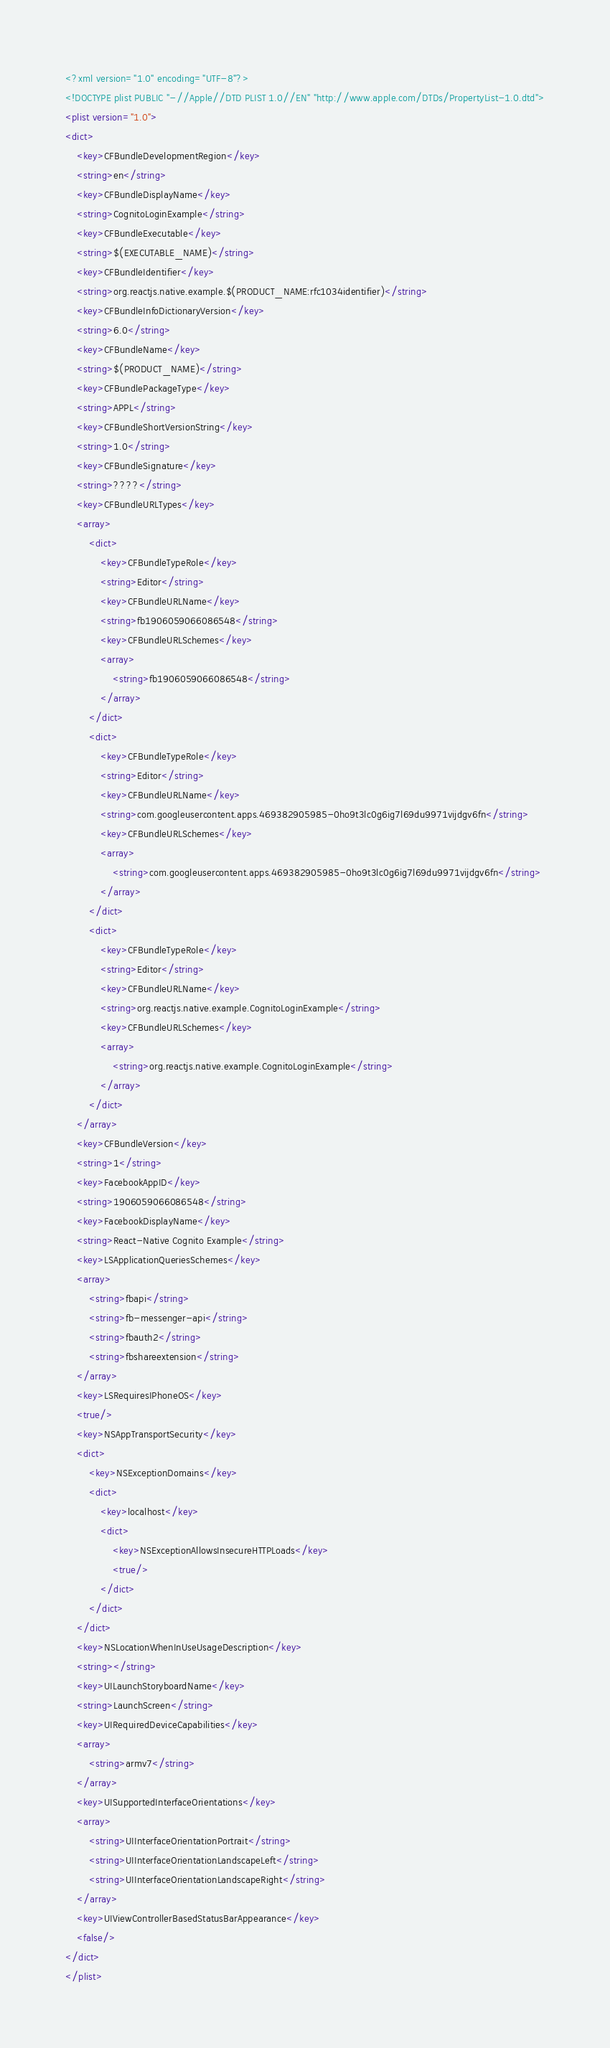<code> <loc_0><loc_0><loc_500><loc_500><_XML_><?xml version="1.0" encoding="UTF-8"?>
<!DOCTYPE plist PUBLIC "-//Apple//DTD PLIST 1.0//EN" "http://www.apple.com/DTDs/PropertyList-1.0.dtd">
<plist version="1.0">
<dict>
	<key>CFBundleDevelopmentRegion</key>
	<string>en</string>
	<key>CFBundleDisplayName</key>
	<string>CognitoLoginExample</string>
	<key>CFBundleExecutable</key>
	<string>$(EXECUTABLE_NAME)</string>
	<key>CFBundleIdentifier</key>
	<string>org.reactjs.native.example.$(PRODUCT_NAME:rfc1034identifier)</string>
	<key>CFBundleInfoDictionaryVersion</key>
	<string>6.0</string>
	<key>CFBundleName</key>
	<string>$(PRODUCT_NAME)</string>
	<key>CFBundlePackageType</key>
	<string>APPL</string>
	<key>CFBundleShortVersionString</key>
	<string>1.0</string>
	<key>CFBundleSignature</key>
	<string>????</string>
	<key>CFBundleURLTypes</key>
	<array>
		<dict>
			<key>CFBundleTypeRole</key>
			<string>Editor</string>
			<key>CFBundleURLName</key>
			<string>fb1906059066086548</string>
			<key>CFBundleURLSchemes</key>
			<array>
				<string>fb1906059066086548</string>
			</array>
		</dict>
		<dict>
			<key>CFBundleTypeRole</key>
			<string>Editor</string>
			<key>CFBundleURLName</key>
			<string>com.googleusercontent.apps.469382905985-0ho9t3lc0g6ig7l69du9971vijdgv6fn</string>
			<key>CFBundleURLSchemes</key>
			<array>
				<string>com.googleusercontent.apps.469382905985-0ho9t3lc0g6ig7l69du9971vijdgv6fn</string>
			</array>
		</dict>
		<dict>
			<key>CFBundleTypeRole</key>
			<string>Editor</string>
			<key>CFBundleURLName</key>
			<string>org.reactjs.native.example.CognitoLoginExample</string>
			<key>CFBundleURLSchemes</key>
			<array>
				<string>org.reactjs.native.example.CognitoLoginExample</string>
			</array>
		</dict>
	</array>
	<key>CFBundleVersion</key>
	<string>1</string>
	<key>FacebookAppID</key>
	<string>1906059066086548</string>
	<key>FacebookDisplayName</key>
	<string>React-Native Cognito Example</string>
	<key>LSApplicationQueriesSchemes</key>
	<array>
		<string>fbapi</string>
		<string>fb-messenger-api</string>
		<string>fbauth2</string>
		<string>fbshareextension</string>
	</array>
	<key>LSRequiresIPhoneOS</key>
	<true/>
	<key>NSAppTransportSecurity</key>
	<dict>
		<key>NSExceptionDomains</key>
		<dict>
			<key>localhost</key>
			<dict>
				<key>NSExceptionAllowsInsecureHTTPLoads</key>
				<true/>
			</dict>
		</dict>
	</dict>
	<key>NSLocationWhenInUseUsageDescription</key>
	<string></string>
	<key>UILaunchStoryboardName</key>
	<string>LaunchScreen</string>
	<key>UIRequiredDeviceCapabilities</key>
	<array>
		<string>armv7</string>
	</array>
	<key>UISupportedInterfaceOrientations</key>
	<array>
		<string>UIInterfaceOrientationPortrait</string>
		<string>UIInterfaceOrientationLandscapeLeft</string>
		<string>UIInterfaceOrientationLandscapeRight</string>
	</array>
	<key>UIViewControllerBasedStatusBarAppearance</key>
	<false/>
</dict>
</plist>
</code> 